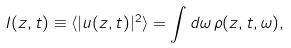Convert formula to latex. <formula><loc_0><loc_0><loc_500><loc_500>I ( z , t ) \equiv \langle | u ( z , t ) | ^ { 2 } \rangle = \int d \omega \, \rho ( z , t , \omega ) ,</formula> 